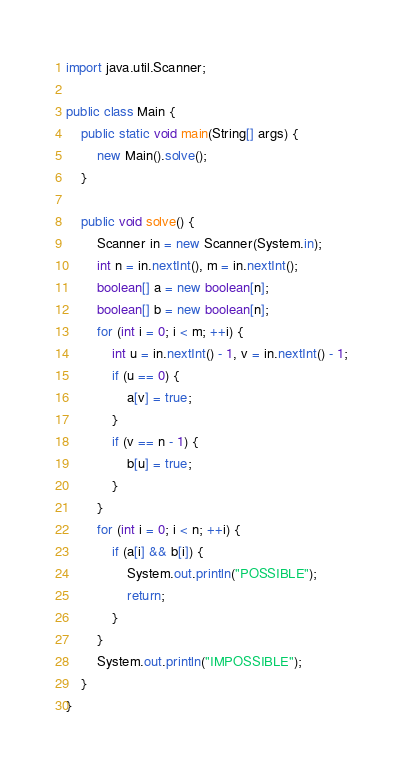Convert code to text. <code><loc_0><loc_0><loc_500><loc_500><_Java_>import java.util.Scanner;

public class Main {
    public static void main(String[] args) {
        new Main().solve();
    }

    public void solve() {
        Scanner in = new Scanner(System.in);
        int n = in.nextInt(), m = in.nextInt();
        boolean[] a = new boolean[n];
        boolean[] b = new boolean[n];
        for (int i = 0; i < m; ++i) {
            int u = in.nextInt() - 1, v = in.nextInt() - 1;
            if (u == 0) {
                a[v] = true;
            }
            if (v == n - 1) {
                b[u] = true;
            }
        }
        for (int i = 0; i < n; ++i) {
            if (a[i] && b[i]) {
                System.out.println("POSSIBLE");
                return;
            }
        }
        System.out.println("IMPOSSIBLE");
    }
}</code> 